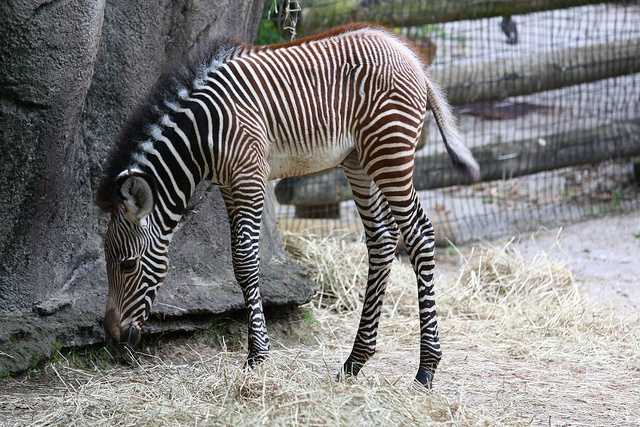Describe the objects in this image and their specific colors. I can see zebra in black, gray, lightgray, and darkgray tones and bird in black, gray, and blue tones in this image. 